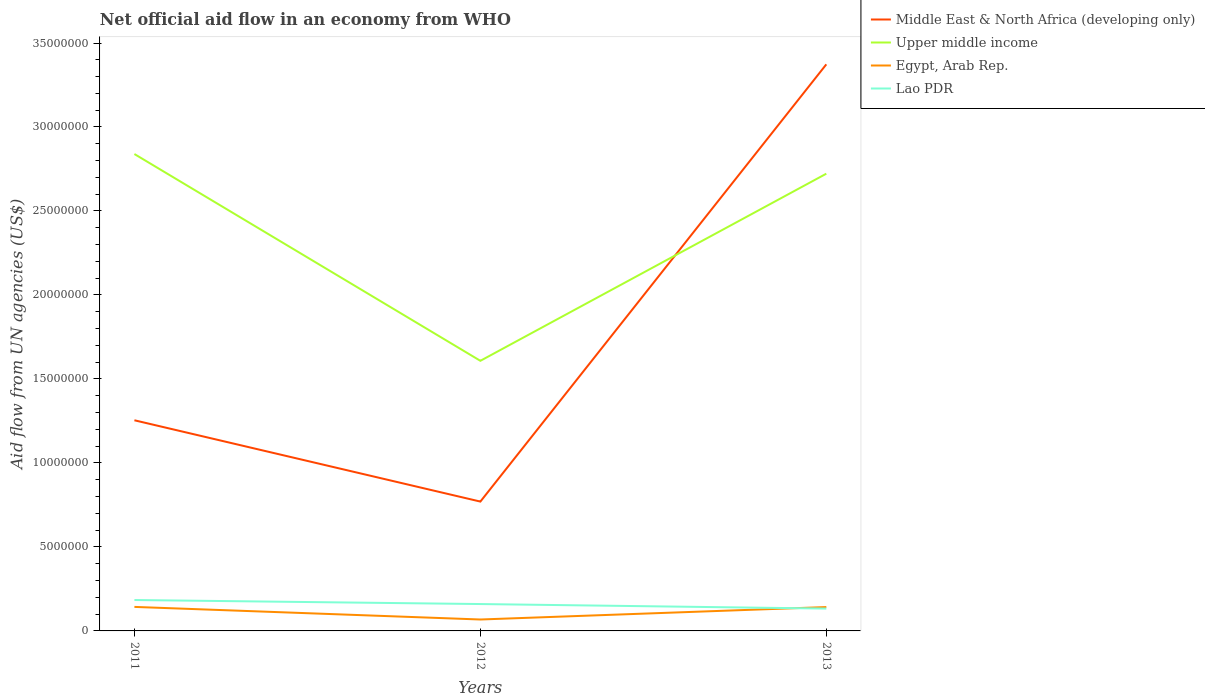Is the number of lines equal to the number of legend labels?
Your response must be concise. Yes. Across all years, what is the maximum net official aid flow in Lao PDR?
Your answer should be compact. 1.33e+06. In which year was the net official aid flow in Upper middle income maximum?
Offer a very short reply. 2012. What is the total net official aid flow in Egypt, Arab Rep. in the graph?
Keep it short and to the point. -7.40e+05. What is the difference between the highest and the second highest net official aid flow in Upper middle income?
Your answer should be compact. 1.23e+07. What is the difference between the highest and the lowest net official aid flow in Egypt, Arab Rep.?
Your answer should be very brief. 2. Is the net official aid flow in Lao PDR strictly greater than the net official aid flow in Upper middle income over the years?
Your response must be concise. Yes. How many years are there in the graph?
Give a very brief answer. 3. What is the difference between two consecutive major ticks on the Y-axis?
Provide a short and direct response. 5.00e+06. Does the graph contain any zero values?
Offer a terse response. No. Does the graph contain grids?
Give a very brief answer. No. Where does the legend appear in the graph?
Give a very brief answer. Top right. How many legend labels are there?
Your response must be concise. 4. What is the title of the graph?
Your response must be concise. Net official aid flow in an economy from WHO. Does "West Bank and Gaza" appear as one of the legend labels in the graph?
Keep it short and to the point. No. What is the label or title of the Y-axis?
Provide a short and direct response. Aid flow from UN agencies (US$). What is the Aid flow from UN agencies (US$) of Middle East & North Africa (developing only) in 2011?
Ensure brevity in your answer.  1.25e+07. What is the Aid flow from UN agencies (US$) in Upper middle income in 2011?
Keep it short and to the point. 2.84e+07. What is the Aid flow from UN agencies (US$) of Egypt, Arab Rep. in 2011?
Give a very brief answer. 1.43e+06. What is the Aid flow from UN agencies (US$) in Lao PDR in 2011?
Your response must be concise. 1.84e+06. What is the Aid flow from UN agencies (US$) in Middle East & North Africa (developing only) in 2012?
Your answer should be compact. 7.70e+06. What is the Aid flow from UN agencies (US$) of Upper middle income in 2012?
Your response must be concise. 1.61e+07. What is the Aid flow from UN agencies (US$) in Egypt, Arab Rep. in 2012?
Your response must be concise. 6.80e+05. What is the Aid flow from UN agencies (US$) of Lao PDR in 2012?
Offer a terse response. 1.60e+06. What is the Aid flow from UN agencies (US$) in Middle East & North Africa (developing only) in 2013?
Provide a short and direct response. 3.37e+07. What is the Aid flow from UN agencies (US$) of Upper middle income in 2013?
Keep it short and to the point. 2.72e+07. What is the Aid flow from UN agencies (US$) in Egypt, Arab Rep. in 2013?
Your answer should be very brief. 1.42e+06. What is the Aid flow from UN agencies (US$) in Lao PDR in 2013?
Provide a succinct answer. 1.33e+06. Across all years, what is the maximum Aid flow from UN agencies (US$) in Middle East & North Africa (developing only)?
Your response must be concise. 3.37e+07. Across all years, what is the maximum Aid flow from UN agencies (US$) in Upper middle income?
Offer a very short reply. 2.84e+07. Across all years, what is the maximum Aid flow from UN agencies (US$) in Egypt, Arab Rep.?
Keep it short and to the point. 1.43e+06. Across all years, what is the maximum Aid flow from UN agencies (US$) in Lao PDR?
Ensure brevity in your answer.  1.84e+06. Across all years, what is the minimum Aid flow from UN agencies (US$) in Middle East & North Africa (developing only)?
Make the answer very short. 7.70e+06. Across all years, what is the minimum Aid flow from UN agencies (US$) of Upper middle income?
Make the answer very short. 1.61e+07. Across all years, what is the minimum Aid flow from UN agencies (US$) of Egypt, Arab Rep.?
Provide a succinct answer. 6.80e+05. Across all years, what is the minimum Aid flow from UN agencies (US$) in Lao PDR?
Your answer should be compact. 1.33e+06. What is the total Aid flow from UN agencies (US$) in Middle East & North Africa (developing only) in the graph?
Keep it short and to the point. 5.40e+07. What is the total Aid flow from UN agencies (US$) in Upper middle income in the graph?
Make the answer very short. 7.17e+07. What is the total Aid flow from UN agencies (US$) of Egypt, Arab Rep. in the graph?
Your answer should be compact. 3.53e+06. What is the total Aid flow from UN agencies (US$) in Lao PDR in the graph?
Make the answer very short. 4.77e+06. What is the difference between the Aid flow from UN agencies (US$) of Middle East & North Africa (developing only) in 2011 and that in 2012?
Your answer should be very brief. 4.84e+06. What is the difference between the Aid flow from UN agencies (US$) of Upper middle income in 2011 and that in 2012?
Give a very brief answer. 1.23e+07. What is the difference between the Aid flow from UN agencies (US$) in Egypt, Arab Rep. in 2011 and that in 2012?
Ensure brevity in your answer.  7.50e+05. What is the difference between the Aid flow from UN agencies (US$) of Lao PDR in 2011 and that in 2012?
Keep it short and to the point. 2.40e+05. What is the difference between the Aid flow from UN agencies (US$) in Middle East & North Africa (developing only) in 2011 and that in 2013?
Make the answer very short. -2.12e+07. What is the difference between the Aid flow from UN agencies (US$) of Upper middle income in 2011 and that in 2013?
Ensure brevity in your answer.  1.17e+06. What is the difference between the Aid flow from UN agencies (US$) in Egypt, Arab Rep. in 2011 and that in 2013?
Ensure brevity in your answer.  10000. What is the difference between the Aid flow from UN agencies (US$) in Lao PDR in 2011 and that in 2013?
Keep it short and to the point. 5.10e+05. What is the difference between the Aid flow from UN agencies (US$) in Middle East & North Africa (developing only) in 2012 and that in 2013?
Your answer should be very brief. -2.60e+07. What is the difference between the Aid flow from UN agencies (US$) in Upper middle income in 2012 and that in 2013?
Your answer should be compact. -1.11e+07. What is the difference between the Aid flow from UN agencies (US$) of Egypt, Arab Rep. in 2012 and that in 2013?
Your response must be concise. -7.40e+05. What is the difference between the Aid flow from UN agencies (US$) in Middle East & North Africa (developing only) in 2011 and the Aid flow from UN agencies (US$) in Upper middle income in 2012?
Your answer should be compact. -3.54e+06. What is the difference between the Aid flow from UN agencies (US$) in Middle East & North Africa (developing only) in 2011 and the Aid flow from UN agencies (US$) in Egypt, Arab Rep. in 2012?
Ensure brevity in your answer.  1.19e+07. What is the difference between the Aid flow from UN agencies (US$) in Middle East & North Africa (developing only) in 2011 and the Aid flow from UN agencies (US$) in Lao PDR in 2012?
Offer a terse response. 1.09e+07. What is the difference between the Aid flow from UN agencies (US$) in Upper middle income in 2011 and the Aid flow from UN agencies (US$) in Egypt, Arab Rep. in 2012?
Your answer should be very brief. 2.77e+07. What is the difference between the Aid flow from UN agencies (US$) in Upper middle income in 2011 and the Aid flow from UN agencies (US$) in Lao PDR in 2012?
Provide a short and direct response. 2.68e+07. What is the difference between the Aid flow from UN agencies (US$) of Egypt, Arab Rep. in 2011 and the Aid flow from UN agencies (US$) of Lao PDR in 2012?
Provide a succinct answer. -1.70e+05. What is the difference between the Aid flow from UN agencies (US$) of Middle East & North Africa (developing only) in 2011 and the Aid flow from UN agencies (US$) of Upper middle income in 2013?
Make the answer very short. -1.47e+07. What is the difference between the Aid flow from UN agencies (US$) of Middle East & North Africa (developing only) in 2011 and the Aid flow from UN agencies (US$) of Egypt, Arab Rep. in 2013?
Your answer should be compact. 1.11e+07. What is the difference between the Aid flow from UN agencies (US$) of Middle East & North Africa (developing only) in 2011 and the Aid flow from UN agencies (US$) of Lao PDR in 2013?
Your answer should be compact. 1.12e+07. What is the difference between the Aid flow from UN agencies (US$) in Upper middle income in 2011 and the Aid flow from UN agencies (US$) in Egypt, Arab Rep. in 2013?
Make the answer very short. 2.70e+07. What is the difference between the Aid flow from UN agencies (US$) of Upper middle income in 2011 and the Aid flow from UN agencies (US$) of Lao PDR in 2013?
Make the answer very short. 2.71e+07. What is the difference between the Aid flow from UN agencies (US$) of Middle East & North Africa (developing only) in 2012 and the Aid flow from UN agencies (US$) of Upper middle income in 2013?
Offer a terse response. -1.95e+07. What is the difference between the Aid flow from UN agencies (US$) in Middle East & North Africa (developing only) in 2012 and the Aid flow from UN agencies (US$) in Egypt, Arab Rep. in 2013?
Your answer should be compact. 6.28e+06. What is the difference between the Aid flow from UN agencies (US$) in Middle East & North Africa (developing only) in 2012 and the Aid flow from UN agencies (US$) in Lao PDR in 2013?
Your answer should be very brief. 6.37e+06. What is the difference between the Aid flow from UN agencies (US$) in Upper middle income in 2012 and the Aid flow from UN agencies (US$) in Egypt, Arab Rep. in 2013?
Your response must be concise. 1.47e+07. What is the difference between the Aid flow from UN agencies (US$) of Upper middle income in 2012 and the Aid flow from UN agencies (US$) of Lao PDR in 2013?
Offer a terse response. 1.48e+07. What is the difference between the Aid flow from UN agencies (US$) in Egypt, Arab Rep. in 2012 and the Aid flow from UN agencies (US$) in Lao PDR in 2013?
Provide a succinct answer. -6.50e+05. What is the average Aid flow from UN agencies (US$) in Middle East & North Africa (developing only) per year?
Your answer should be compact. 1.80e+07. What is the average Aid flow from UN agencies (US$) of Upper middle income per year?
Offer a very short reply. 2.39e+07. What is the average Aid flow from UN agencies (US$) of Egypt, Arab Rep. per year?
Ensure brevity in your answer.  1.18e+06. What is the average Aid flow from UN agencies (US$) of Lao PDR per year?
Keep it short and to the point. 1.59e+06. In the year 2011, what is the difference between the Aid flow from UN agencies (US$) in Middle East & North Africa (developing only) and Aid flow from UN agencies (US$) in Upper middle income?
Offer a very short reply. -1.58e+07. In the year 2011, what is the difference between the Aid flow from UN agencies (US$) of Middle East & North Africa (developing only) and Aid flow from UN agencies (US$) of Egypt, Arab Rep.?
Your answer should be compact. 1.11e+07. In the year 2011, what is the difference between the Aid flow from UN agencies (US$) in Middle East & North Africa (developing only) and Aid flow from UN agencies (US$) in Lao PDR?
Offer a terse response. 1.07e+07. In the year 2011, what is the difference between the Aid flow from UN agencies (US$) in Upper middle income and Aid flow from UN agencies (US$) in Egypt, Arab Rep.?
Give a very brief answer. 2.70e+07. In the year 2011, what is the difference between the Aid flow from UN agencies (US$) of Upper middle income and Aid flow from UN agencies (US$) of Lao PDR?
Offer a terse response. 2.66e+07. In the year 2011, what is the difference between the Aid flow from UN agencies (US$) of Egypt, Arab Rep. and Aid flow from UN agencies (US$) of Lao PDR?
Your response must be concise. -4.10e+05. In the year 2012, what is the difference between the Aid flow from UN agencies (US$) in Middle East & North Africa (developing only) and Aid flow from UN agencies (US$) in Upper middle income?
Keep it short and to the point. -8.38e+06. In the year 2012, what is the difference between the Aid flow from UN agencies (US$) of Middle East & North Africa (developing only) and Aid flow from UN agencies (US$) of Egypt, Arab Rep.?
Provide a short and direct response. 7.02e+06. In the year 2012, what is the difference between the Aid flow from UN agencies (US$) in Middle East & North Africa (developing only) and Aid flow from UN agencies (US$) in Lao PDR?
Provide a short and direct response. 6.10e+06. In the year 2012, what is the difference between the Aid flow from UN agencies (US$) of Upper middle income and Aid flow from UN agencies (US$) of Egypt, Arab Rep.?
Your answer should be very brief. 1.54e+07. In the year 2012, what is the difference between the Aid flow from UN agencies (US$) in Upper middle income and Aid flow from UN agencies (US$) in Lao PDR?
Offer a very short reply. 1.45e+07. In the year 2012, what is the difference between the Aid flow from UN agencies (US$) of Egypt, Arab Rep. and Aid flow from UN agencies (US$) of Lao PDR?
Offer a very short reply. -9.20e+05. In the year 2013, what is the difference between the Aid flow from UN agencies (US$) in Middle East & North Africa (developing only) and Aid flow from UN agencies (US$) in Upper middle income?
Provide a short and direct response. 6.51e+06. In the year 2013, what is the difference between the Aid flow from UN agencies (US$) in Middle East & North Africa (developing only) and Aid flow from UN agencies (US$) in Egypt, Arab Rep.?
Keep it short and to the point. 3.23e+07. In the year 2013, what is the difference between the Aid flow from UN agencies (US$) of Middle East & North Africa (developing only) and Aid flow from UN agencies (US$) of Lao PDR?
Offer a terse response. 3.24e+07. In the year 2013, what is the difference between the Aid flow from UN agencies (US$) of Upper middle income and Aid flow from UN agencies (US$) of Egypt, Arab Rep.?
Your response must be concise. 2.58e+07. In the year 2013, what is the difference between the Aid flow from UN agencies (US$) in Upper middle income and Aid flow from UN agencies (US$) in Lao PDR?
Make the answer very short. 2.59e+07. What is the ratio of the Aid flow from UN agencies (US$) of Middle East & North Africa (developing only) in 2011 to that in 2012?
Offer a very short reply. 1.63. What is the ratio of the Aid flow from UN agencies (US$) in Upper middle income in 2011 to that in 2012?
Provide a short and direct response. 1.77. What is the ratio of the Aid flow from UN agencies (US$) of Egypt, Arab Rep. in 2011 to that in 2012?
Offer a terse response. 2.1. What is the ratio of the Aid flow from UN agencies (US$) of Lao PDR in 2011 to that in 2012?
Provide a short and direct response. 1.15. What is the ratio of the Aid flow from UN agencies (US$) of Middle East & North Africa (developing only) in 2011 to that in 2013?
Ensure brevity in your answer.  0.37. What is the ratio of the Aid flow from UN agencies (US$) of Upper middle income in 2011 to that in 2013?
Provide a short and direct response. 1.04. What is the ratio of the Aid flow from UN agencies (US$) in Egypt, Arab Rep. in 2011 to that in 2013?
Provide a succinct answer. 1.01. What is the ratio of the Aid flow from UN agencies (US$) of Lao PDR in 2011 to that in 2013?
Give a very brief answer. 1.38. What is the ratio of the Aid flow from UN agencies (US$) of Middle East & North Africa (developing only) in 2012 to that in 2013?
Give a very brief answer. 0.23. What is the ratio of the Aid flow from UN agencies (US$) of Upper middle income in 2012 to that in 2013?
Keep it short and to the point. 0.59. What is the ratio of the Aid flow from UN agencies (US$) in Egypt, Arab Rep. in 2012 to that in 2013?
Offer a terse response. 0.48. What is the ratio of the Aid flow from UN agencies (US$) in Lao PDR in 2012 to that in 2013?
Keep it short and to the point. 1.2. What is the difference between the highest and the second highest Aid flow from UN agencies (US$) in Middle East & North Africa (developing only)?
Offer a terse response. 2.12e+07. What is the difference between the highest and the second highest Aid flow from UN agencies (US$) of Upper middle income?
Provide a succinct answer. 1.17e+06. What is the difference between the highest and the second highest Aid flow from UN agencies (US$) in Egypt, Arab Rep.?
Your answer should be very brief. 10000. What is the difference between the highest and the lowest Aid flow from UN agencies (US$) of Middle East & North Africa (developing only)?
Your answer should be very brief. 2.60e+07. What is the difference between the highest and the lowest Aid flow from UN agencies (US$) in Upper middle income?
Make the answer very short. 1.23e+07. What is the difference between the highest and the lowest Aid flow from UN agencies (US$) of Egypt, Arab Rep.?
Your response must be concise. 7.50e+05. What is the difference between the highest and the lowest Aid flow from UN agencies (US$) in Lao PDR?
Offer a very short reply. 5.10e+05. 